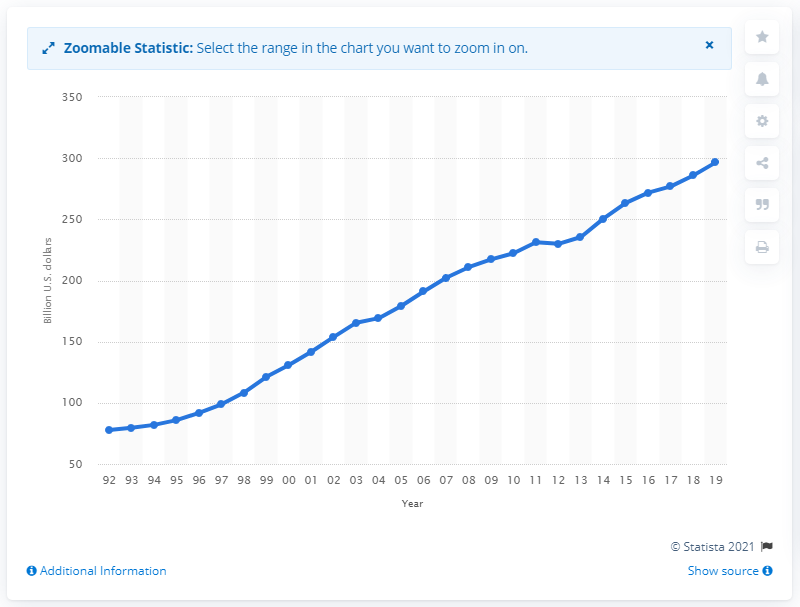Mention a couple of crucial points in this snapshot. In the United States in 2019, pharmacy and drug store sales totaled 296.56 billion dollars. 